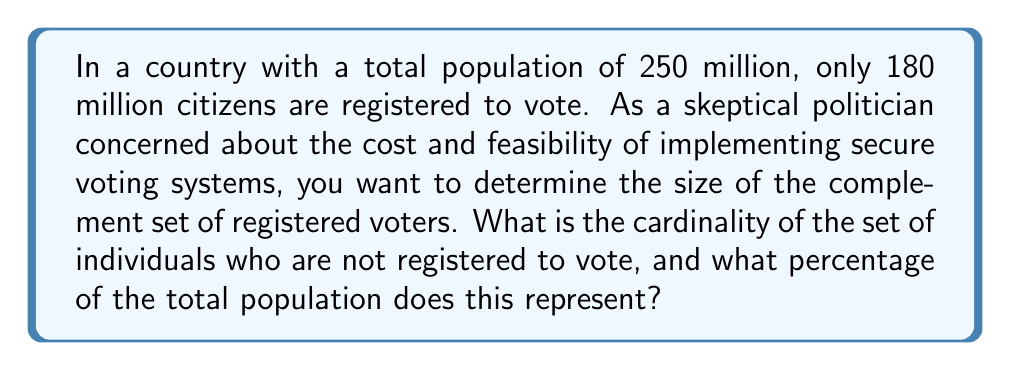Can you solve this math problem? Let's approach this step-by-step:

1) Define our sets:
   $U$ = Universal set (total population)
   $R$ = Set of registered voters
   $R^c$ = Complement of $R$ (not registered voters)

2) Given information:
   $|U| = 250$ million
   $|R| = 180$ million

3) To find $|R^c|$, we use the complement rule:
   $|R^c| = |U| - |R|$

4) Substituting the values:
   $|R^c| = 250$ million $- 180$ million $= 70$ million

5) To calculate the percentage, we use:
   Percentage $= \frac{|R^c|}{|U|} \times 100\%$

6) Substituting the values:
   Percentage $= \frac{70 \text{ million}}{250 \text{ million}} \times 100\% = 0.28 \times 100\% = 28\%$

Thus, 70 million people are not registered to vote, representing 28% of the total population.
Answer: The cardinality of the set of individuals who are not registered to vote is 70 million, which represents 28% of the total population. 